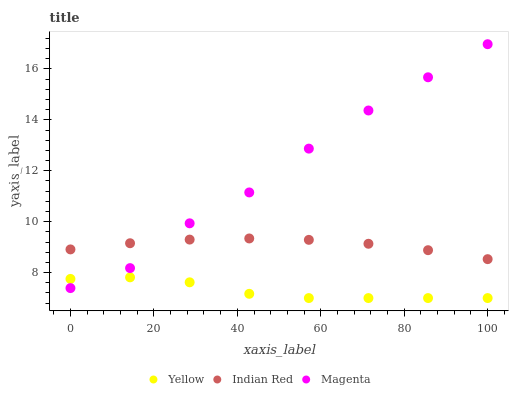Does Yellow have the minimum area under the curve?
Answer yes or no. Yes. Does Magenta have the maximum area under the curve?
Answer yes or no. Yes. Does Indian Red have the minimum area under the curve?
Answer yes or no. No. Does Indian Red have the maximum area under the curve?
Answer yes or no. No. Is Indian Red the smoothest?
Answer yes or no. Yes. Is Magenta the roughest?
Answer yes or no. Yes. Is Yellow the smoothest?
Answer yes or no. No. Is Yellow the roughest?
Answer yes or no. No. Does Yellow have the lowest value?
Answer yes or no. Yes. Does Indian Red have the lowest value?
Answer yes or no. No. Does Magenta have the highest value?
Answer yes or no. Yes. Does Indian Red have the highest value?
Answer yes or no. No. Is Yellow less than Indian Red?
Answer yes or no. Yes. Is Indian Red greater than Yellow?
Answer yes or no. Yes. Does Magenta intersect Yellow?
Answer yes or no. Yes. Is Magenta less than Yellow?
Answer yes or no. No. Is Magenta greater than Yellow?
Answer yes or no. No. Does Yellow intersect Indian Red?
Answer yes or no. No. 